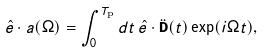Convert formula to latex. <formula><loc_0><loc_0><loc_500><loc_500>\hat { e } \cdot a ( \Omega ) = \int _ { 0 } ^ { T _ { \text  p}}dt \, \hat{e} \cdot \ddot{\mathbf D}(t)\exp(i\Omega t),</formula> 